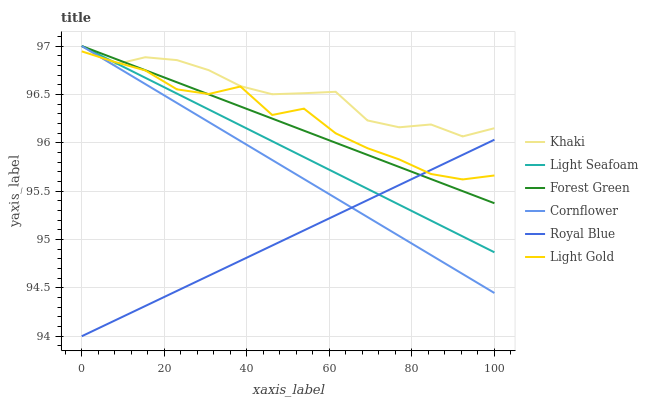Does Royal Blue have the minimum area under the curve?
Answer yes or no. Yes. Does Khaki have the maximum area under the curve?
Answer yes or no. Yes. Does Khaki have the minimum area under the curve?
Answer yes or no. No. Does Royal Blue have the maximum area under the curve?
Answer yes or no. No. Is Royal Blue the smoothest?
Answer yes or no. Yes. Is Light Gold the roughest?
Answer yes or no. Yes. Is Khaki the smoothest?
Answer yes or no. No. Is Khaki the roughest?
Answer yes or no. No. Does Royal Blue have the lowest value?
Answer yes or no. Yes. Does Khaki have the lowest value?
Answer yes or no. No. Does Light Seafoam have the highest value?
Answer yes or no. Yes. Does Royal Blue have the highest value?
Answer yes or no. No. Is Royal Blue less than Khaki?
Answer yes or no. Yes. Is Khaki greater than Royal Blue?
Answer yes or no. Yes. Does Cornflower intersect Forest Green?
Answer yes or no. Yes. Is Cornflower less than Forest Green?
Answer yes or no. No. Is Cornflower greater than Forest Green?
Answer yes or no. No. Does Royal Blue intersect Khaki?
Answer yes or no. No. 